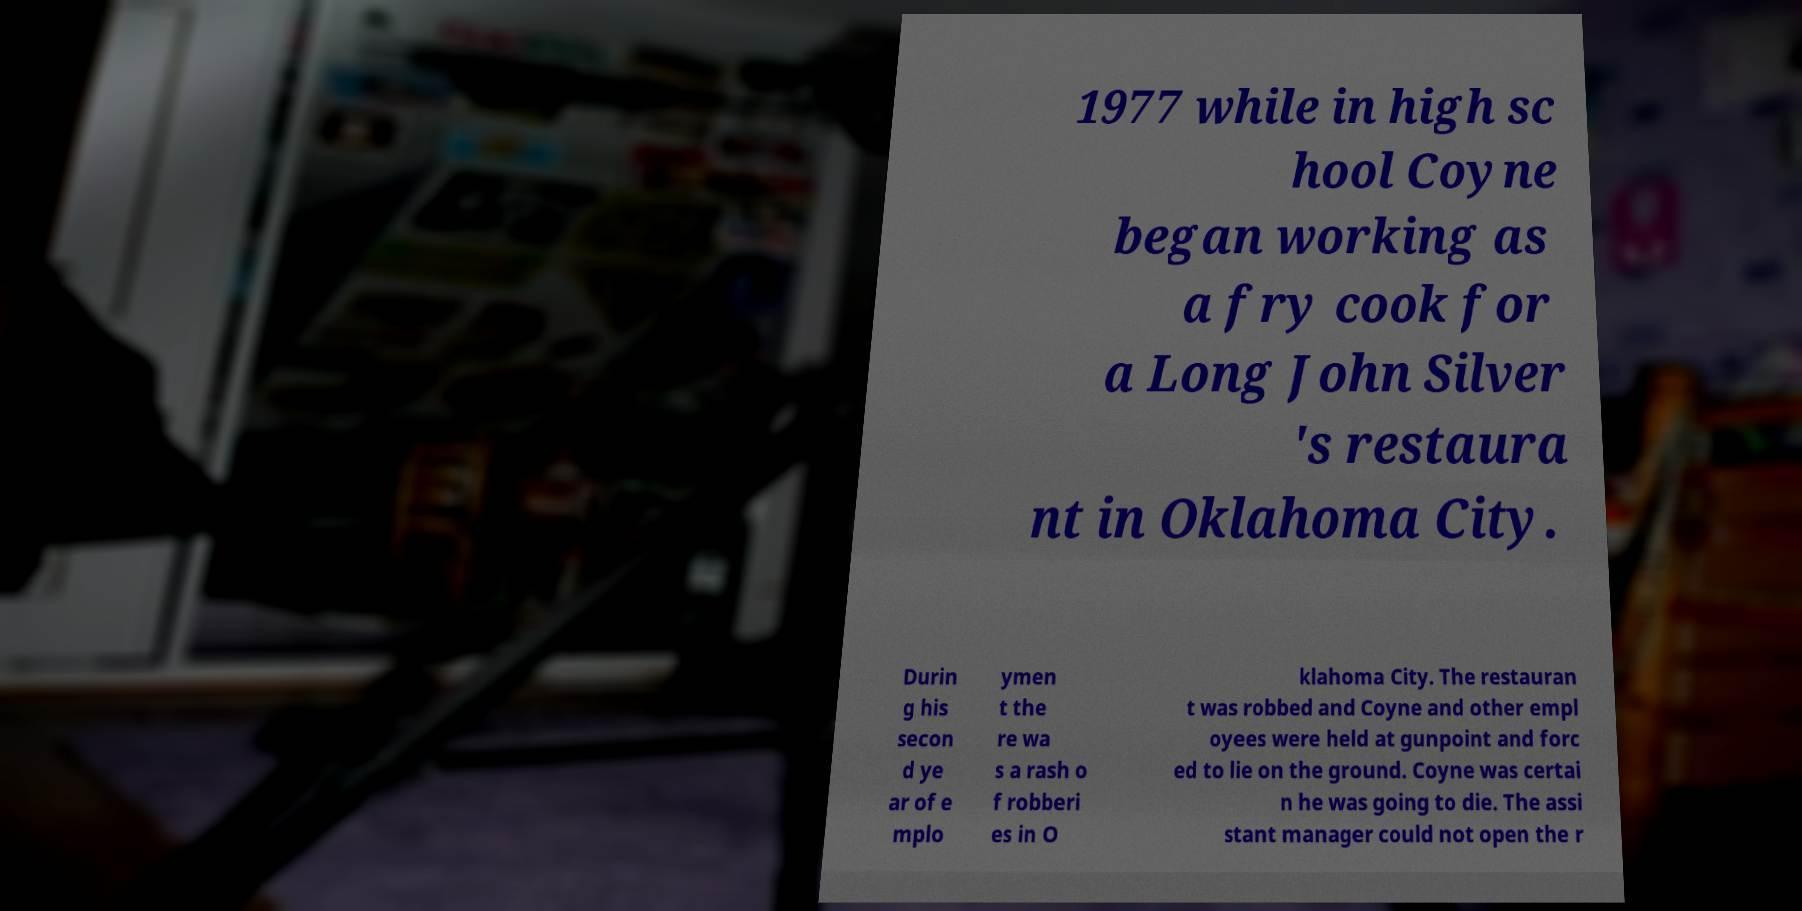What messages or text are displayed in this image? I need them in a readable, typed format. 1977 while in high sc hool Coyne began working as a fry cook for a Long John Silver 's restaura nt in Oklahoma City. Durin g his secon d ye ar of e mplo ymen t the re wa s a rash o f robberi es in O klahoma City. The restauran t was robbed and Coyne and other empl oyees were held at gunpoint and forc ed to lie on the ground. Coyne was certai n he was going to die. The assi stant manager could not open the r 